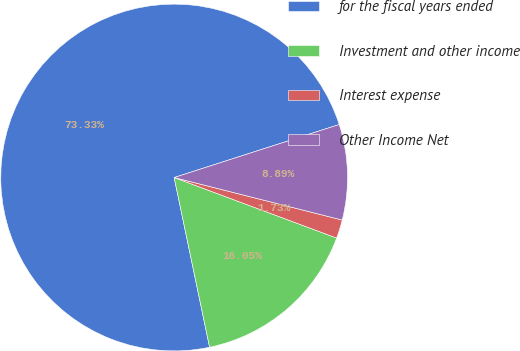Convert chart to OTSL. <chart><loc_0><loc_0><loc_500><loc_500><pie_chart><fcel>for the fiscal years ended<fcel>Investment and other income<fcel>Interest expense<fcel>Other Income Net<nl><fcel>73.34%<fcel>16.05%<fcel>1.73%<fcel>8.89%<nl></chart> 